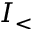Convert formula to latex. <formula><loc_0><loc_0><loc_500><loc_500>I _ { < }</formula> 